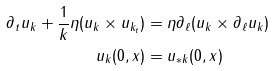<formula> <loc_0><loc_0><loc_500><loc_500>\partial _ { t } u _ { k } + \frac { 1 } { k } \eta ( u _ { k } \times u _ { k _ { t } } ) & = \eta \partial _ { \ell } ( u _ { k } \times \partial _ { \ell } u _ { k } ) \\ u _ { k } ( 0 , x ) & = u _ { * k } ( 0 , x )</formula> 